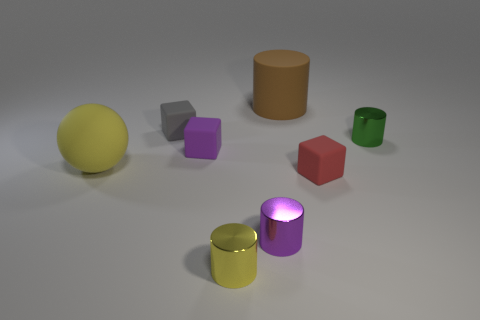Is there any other thing that is the same shape as the big yellow object?
Ensure brevity in your answer.  No. What number of other objects are there of the same color as the big rubber cylinder?
Offer a terse response. 0. Is the color of the large ball the same as the tiny cylinder left of the purple metallic object?
Provide a short and direct response. Yes. There is a yellow object that is behind the yellow metallic cylinder; how many small rubber blocks are behind it?
Provide a succinct answer. 2. What material is the yellow thing that is to the left of the purple thing that is behind the small red block to the right of the yellow matte sphere?
Offer a terse response. Rubber. There is a thing that is on the left side of the purple matte object and right of the large sphere; what material is it?
Keep it short and to the point. Rubber. How many purple things are the same shape as the yellow metallic object?
Provide a succinct answer. 1. How big is the yellow thing behind the yellow object to the right of the yellow matte sphere?
Provide a short and direct response. Large. There is a large rubber object that is left of the tiny yellow metal cylinder; does it have the same color as the tiny metal cylinder behind the small red thing?
Provide a short and direct response. No. What number of purple blocks are in front of the small thing right of the matte block that is in front of the matte ball?
Keep it short and to the point. 1. 